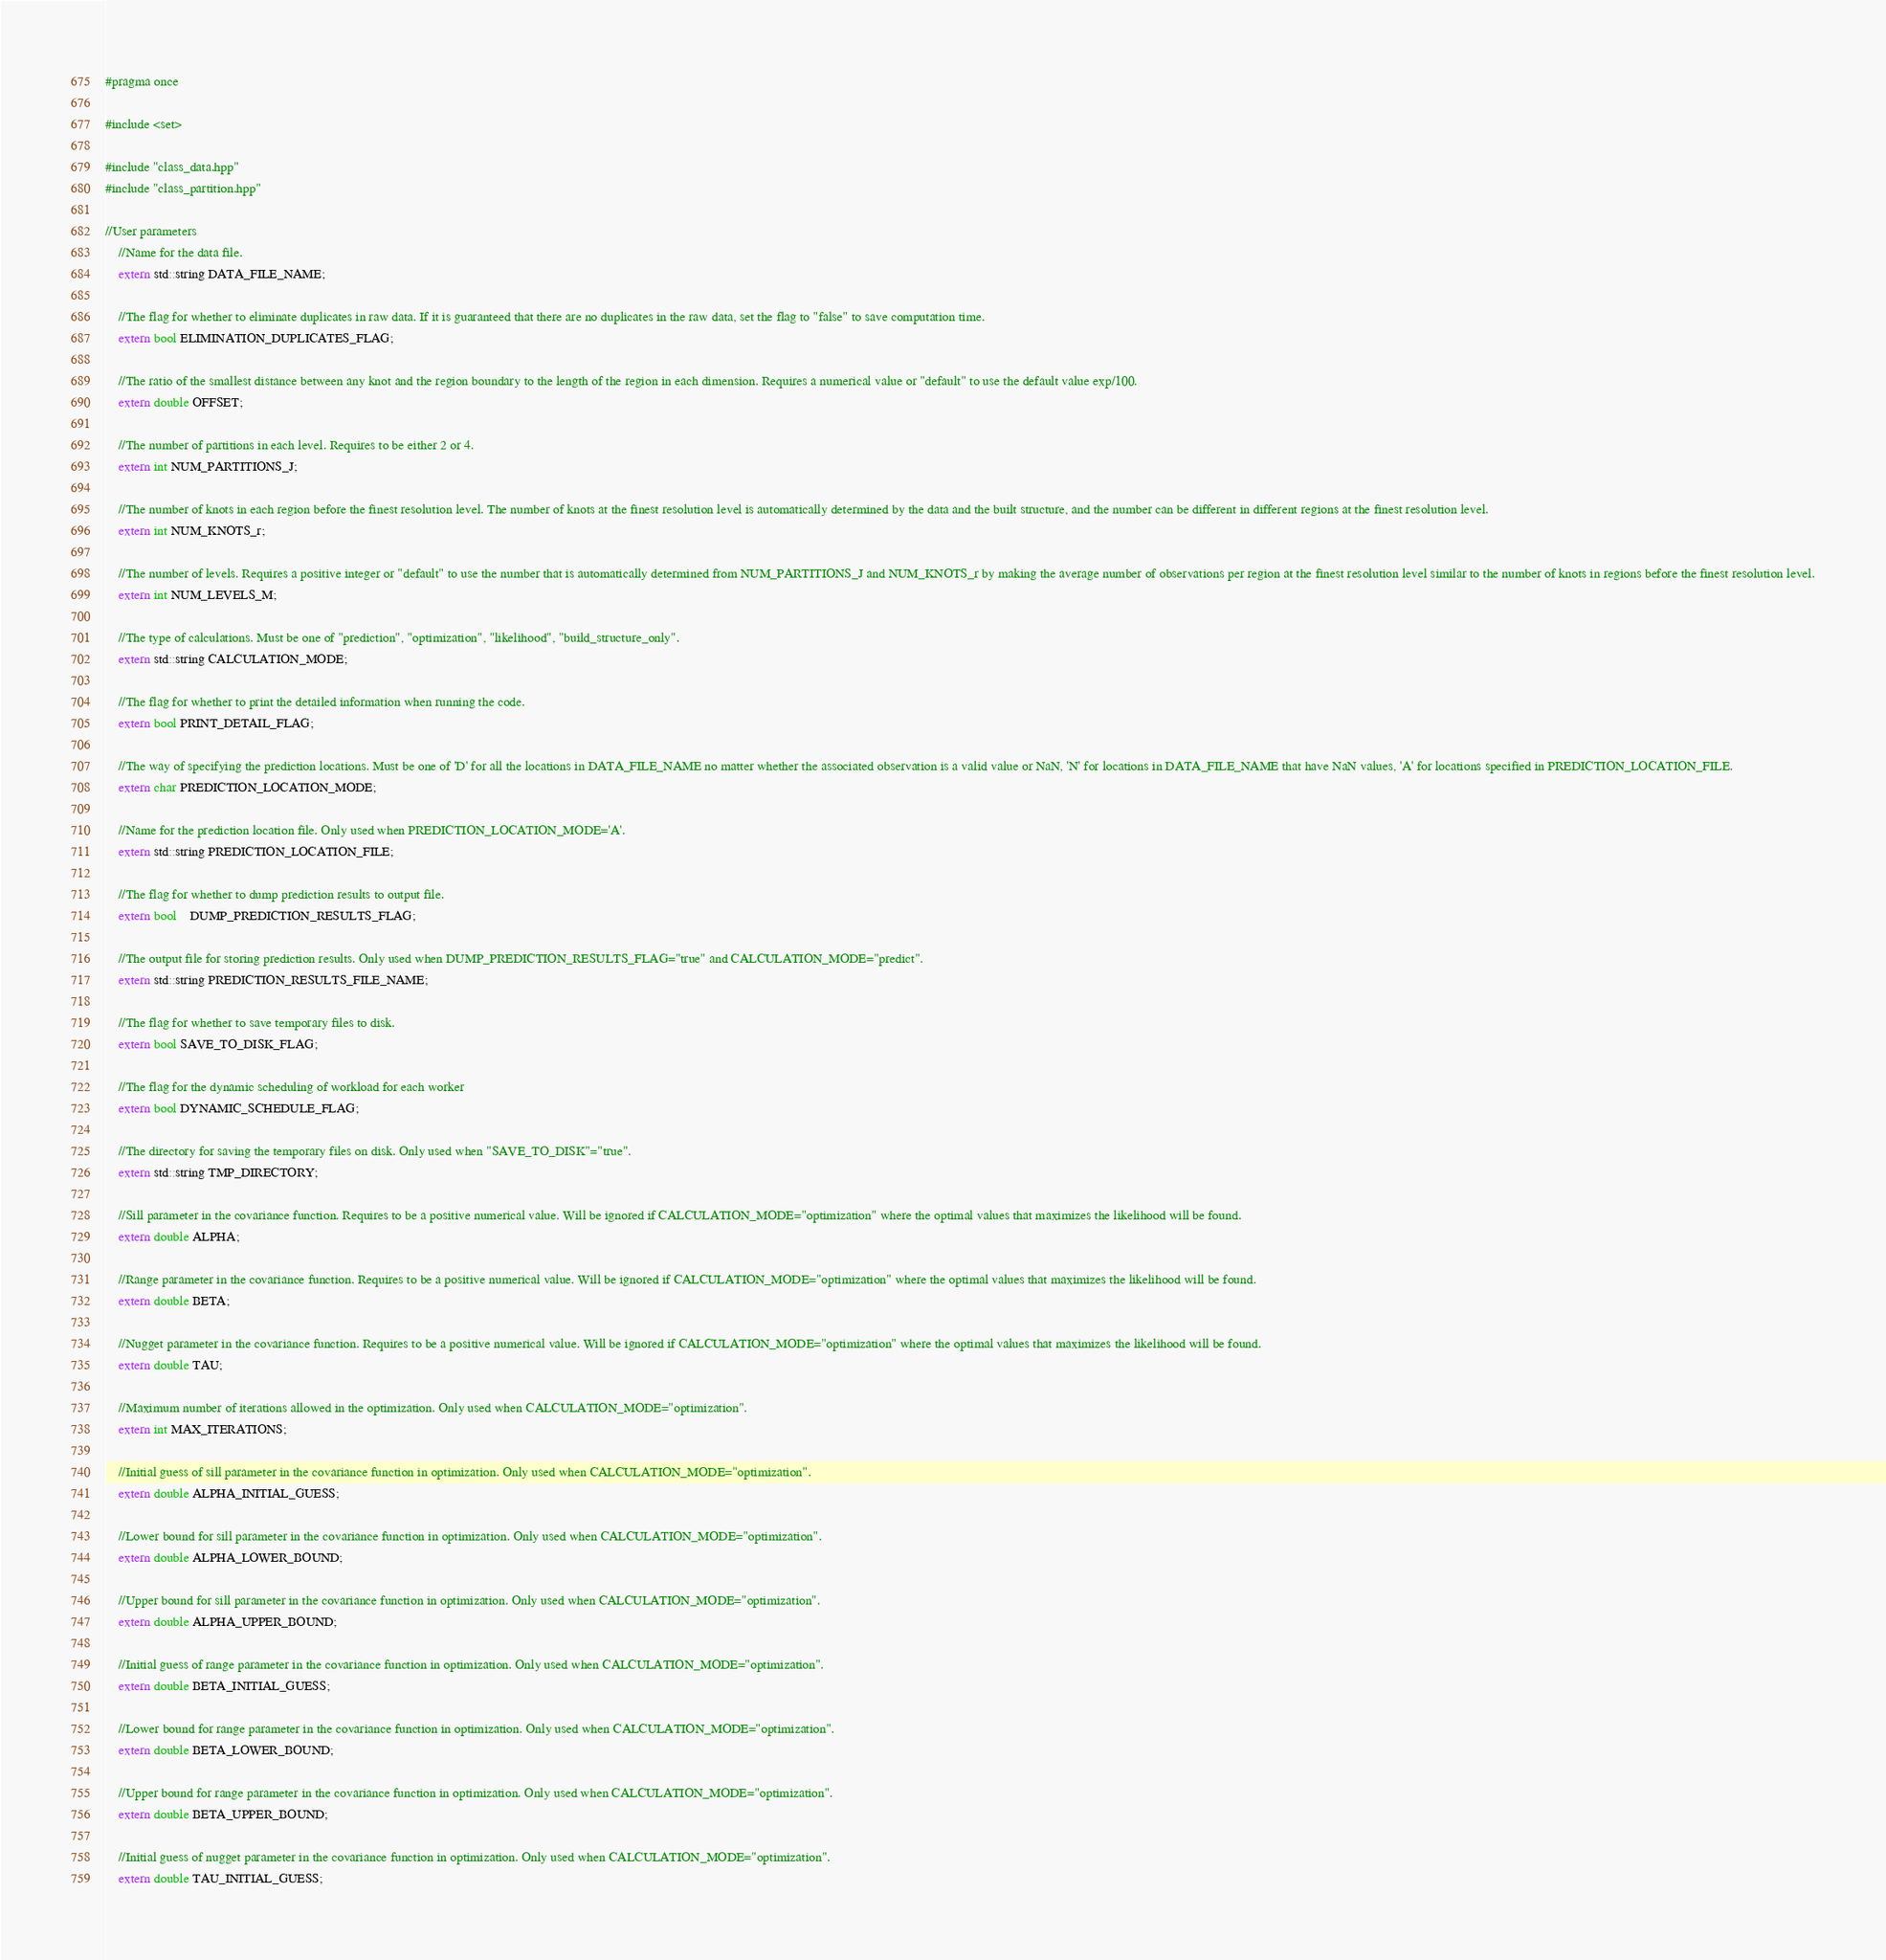<code> <loc_0><loc_0><loc_500><loc_500><_C++_>#pragma once

#include <set>

#include "class_data.hpp"
#include "class_partition.hpp"

//User parameters
    //Name for the data file.
    extern std::string DATA_FILE_NAME;

    //The flag for whether to eliminate duplicates in raw data. If it is guaranteed that there are no duplicates in the raw data, set the flag to "false" to save computation time.
    extern bool ELIMINATION_DUPLICATES_FLAG;

    //The ratio of the smallest distance between any knot and the region boundary to the length of the region in each dimension. Requires a numerical value or "default" to use the default value exp/100.
    extern double OFFSET;

    //The number of partitions in each level. Requires to be either 2 or 4.
    extern int NUM_PARTITIONS_J;

    //The number of knots in each region before the finest resolution level. The number of knots at the finest resolution level is automatically determined by the data and the built structure, and the number can be different in different regions at the finest resolution level.
    extern int NUM_KNOTS_r;

    //The number of levels. Requires a positive integer or "default" to use the number that is automatically determined from NUM_PARTITIONS_J and NUM_KNOTS_r by making the average number of observations per region at the finest resolution level similar to the number of knots in regions before the finest resolution level.
    extern int NUM_LEVELS_M;

    //The type of calculations. Must be one of "prediction", "optimization", "likelihood", "build_structure_only".
    extern std::string CALCULATION_MODE;

    //The flag for whether to print the detailed information when running the code.
    extern bool PRINT_DETAIL_FLAG;

    //The way of specifying the prediction locations. Must be one of 'D' for all the locations in DATA_FILE_NAME no matter whether the associated observation is a valid value or NaN, 'N' for locations in DATA_FILE_NAME that have NaN values, 'A' for locations specified in PREDICTION_LOCATION_FILE.
    extern char PREDICTION_LOCATION_MODE;

    //Name for the prediction location file. Only used when PREDICTION_LOCATION_MODE='A'.
    extern std::string PREDICTION_LOCATION_FILE;

    //The flag for whether to dump prediction results to output file.
    extern bool	DUMP_PREDICTION_RESULTS_FLAG;

    //The output file for storing prediction results. Only used when DUMP_PREDICTION_RESULTS_FLAG="true" and CALCULATION_MODE="predict".
    extern std::string PREDICTION_RESULTS_FILE_NAME;

    //The flag for whether to save temporary files to disk.
	extern bool SAVE_TO_DISK_FLAG;

    //The flag for the dynamic scheduling of workload for each worker
    extern bool DYNAMIC_SCHEDULE_FLAG;

    //The directory for saving the temporary files on disk. Only used when "SAVE_TO_DISK"="true".
	extern std::string TMP_DIRECTORY;

    //Sill parameter in the covariance function. Requires to be a positive numerical value. Will be ignored if CALCULATION_MODE="optimization" where the optimal values that maximizes the likelihood will be found.
	extern double ALPHA;

    //Range parameter in the covariance function. Requires to be a positive numerical value. Will be ignored if CALCULATION_MODE="optimization" where the optimal values that maximizes the likelihood will be found.
	extern double BETA;

    //Nugget parameter in the covariance function. Requires to be a positive numerical value. Will be ignored if CALCULATION_MODE="optimization" where the optimal values that maximizes the likelihood will be found.
	extern double TAU;

    //Maximum number of iterations allowed in the optimization. Only used when CALCULATION_MODE="optimization".
	extern int MAX_ITERATIONS;

    //Initial guess of sill parameter in the covariance function in optimization. Only used when CALCULATION_MODE="optimization".
	extern double ALPHA_INITIAL_GUESS;

    //Lower bound for sill parameter in the covariance function in optimization. Only used when CALCULATION_MODE="optimization".
	extern double ALPHA_LOWER_BOUND;

    //Upper bound for sill parameter in the covariance function in optimization. Only used when CALCULATION_MODE="optimization".
	extern double ALPHA_UPPER_BOUND;

    //Initial guess of range parameter in the covariance function in optimization. Only used when CALCULATION_MODE="optimization".
	extern double BETA_INITIAL_GUESS;

    //Lower bound for range parameter in the covariance function in optimization. Only used when CALCULATION_MODE="optimization".
	extern double BETA_LOWER_BOUND;

    //Upper bound for range parameter in the covariance function in optimization. Only used when CALCULATION_MODE="optimization".
	extern double BETA_UPPER_BOUND;

    //Initial guess of nugget parameter in the covariance function in optimization. Only used when CALCULATION_MODE="optimization".
	extern double TAU_INITIAL_GUESS;
</code> 